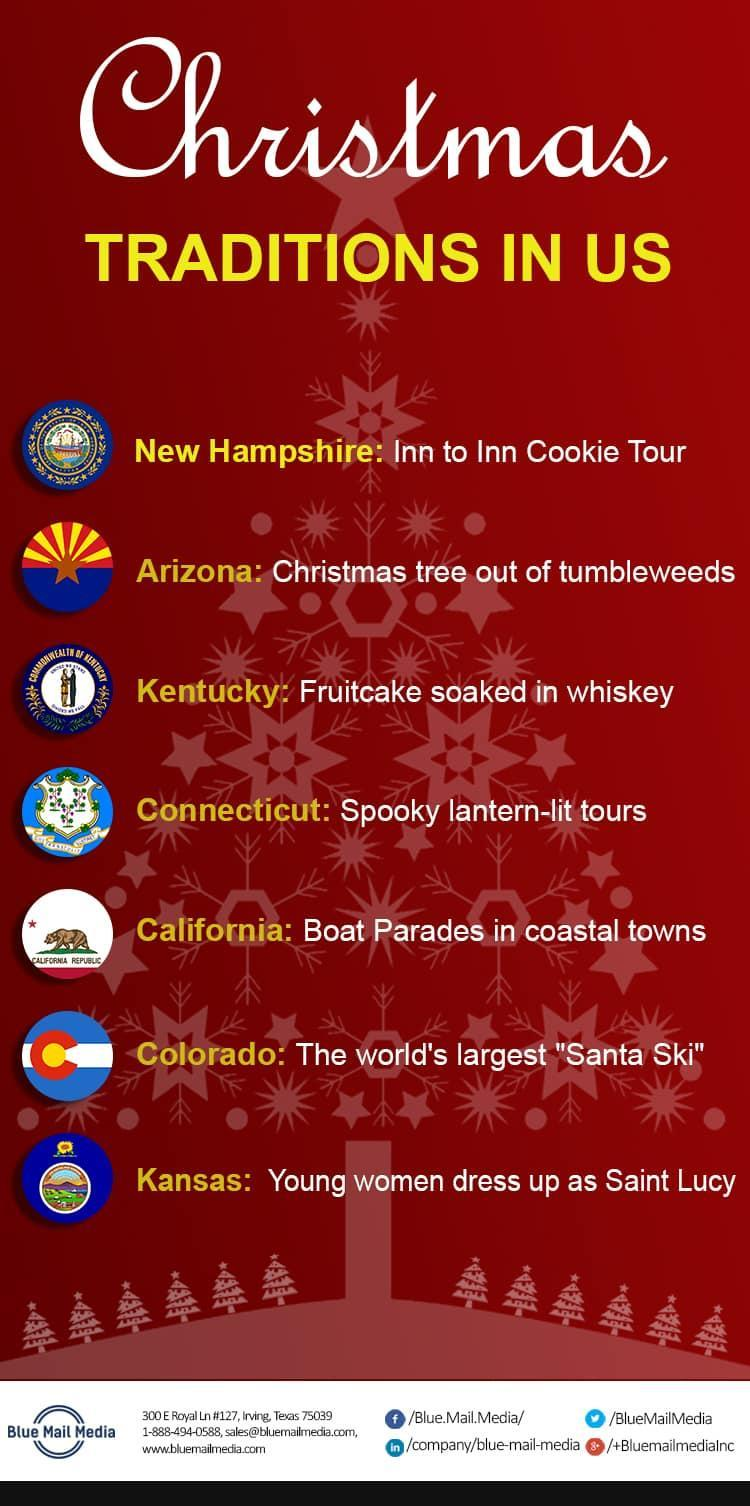what is written inside the flag of california
Answer the question with a short phrase. california republic what is the colour in which the states are written, yellow or red? yellow where is blue media located texas 